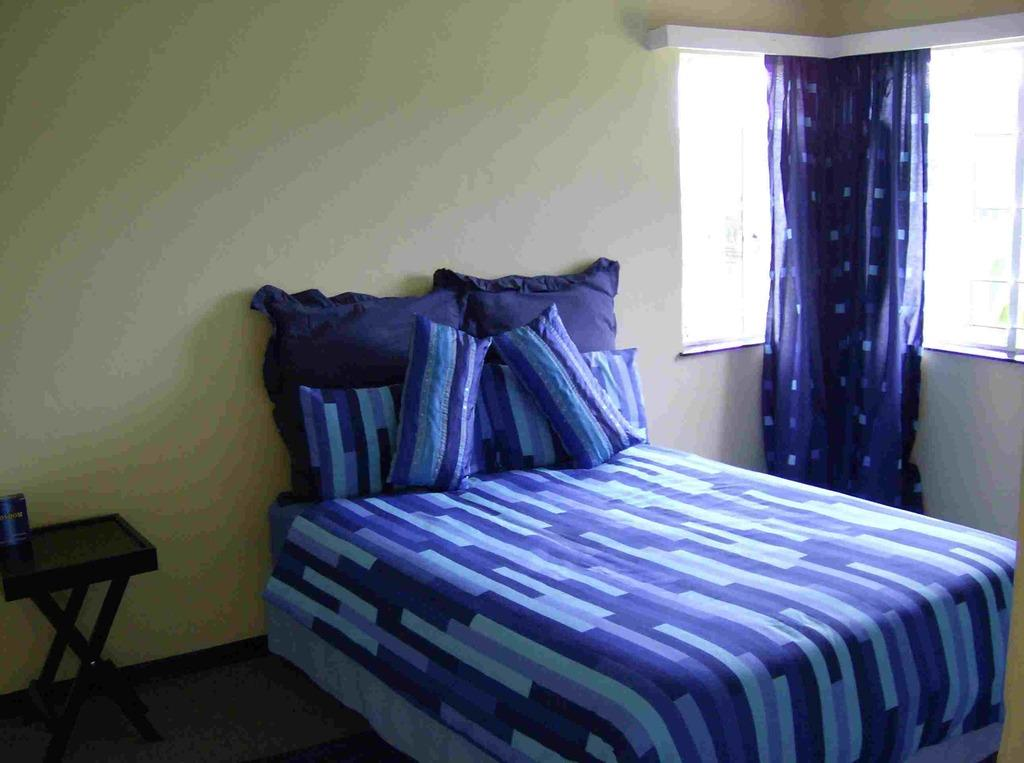What piece of furniture is present in the room for sleeping? There is a bed in the room. What is placed on the bed for comfort? There is a pillow on the bed. What piece of furniture is present in the room for placing items? There is a table in the room. What is on the table? There is a tin on the table. How is natural light controlled in the room? There is a window in the room with curtains hanging on it. What type of discovery was made in the room regarding muscle form? There is no mention of any discovery or muscle form in the image or the provided facts. 